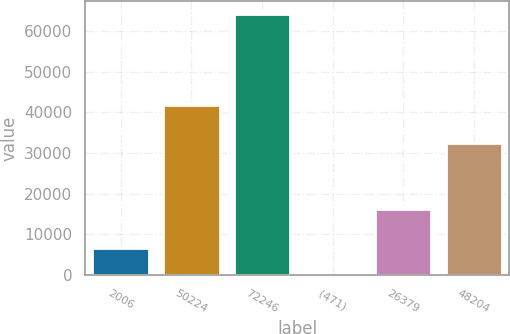Convert chart to OTSL. <chart><loc_0><loc_0><loc_500><loc_500><bar_chart><fcel>2006<fcel>50224<fcel>72246<fcel>(471)<fcel>26379<fcel>48204<nl><fcel>6757.6<fcel>41910<fcel>64102<fcel>386<fcel>16172<fcel>32376<nl></chart> 